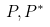Convert formula to latex. <formula><loc_0><loc_0><loc_500><loc_500>P , P ^ { * }</formula> 